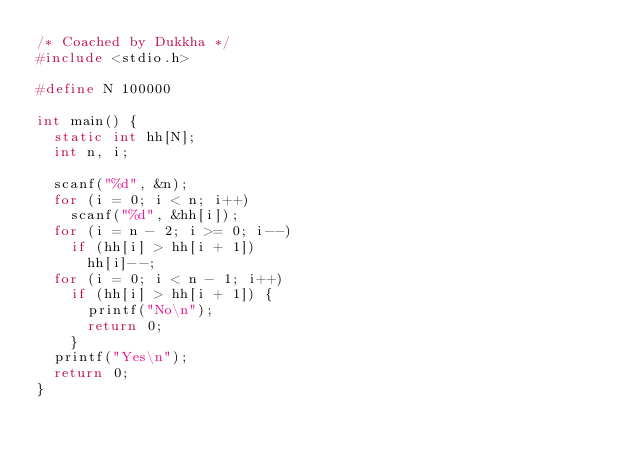Convert code to text. <code><loc_0><loc_0><loc_500><loc_500><_C_>/* Coached by Dukkha */
#include <stdio.h>

#define N 100000

int main() {
	static int hh[N];
	int n, i;

	scanf("%d", &n);
	for (i = 0; i < n; i++)
		scanf("%d", &hh[i]);
	for (i = n - 2; i >= 0; i--)
		if (hh[i] > hh[i + 1])
			hh[i]--;
	for (i = 0; i < n - 1; i++)
		if (hh[i] > hh[i + 1]) {
			printf("No\n");
			return 0;
		}
	printf("Yes\n");
	return 0;
}
</code> 